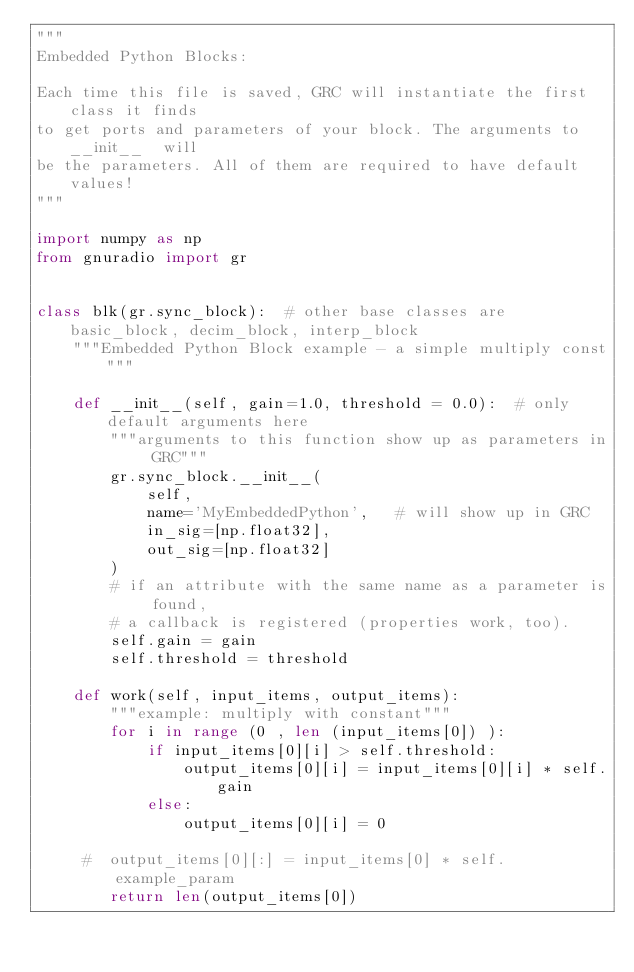<code> <loc_0><loc_0><loc_500><loc_500><_Python_>"""
Embedded Python Blocks:

Each time this file is saved, GRC will instantiate the first class it finds
to get ports and parameters of your block. The arguments to __init__  will
be the parameters. All of them are required to have default values!
"""

import numpy as np
from gnuradio import gr


class blk(gr.sync_block):  # other base classes are basic_block, decim_block, interp_block
    """Embedded Python Block example - a simple multiply const"""

    def __init__(self, gain=1.0, threshold = 0.0):  # only default arguments here
        """arguments to this function show up as parameters in GRC"""
        gr.sync_block.__init__(
            self,
            name='MyEmbeddedPython',   # will show up in GRC
            in_sig=[np.float32],
            out_sig=[np.float32]
        )
        # if an attribute with the same name as a parameter is found,
        # a callback is registered (properties work, too).
        self.gain = gain
        self.threshold = threshold 

    def work(self, input_items, output_items):
        """example: multiply with constant"""
        for i in range (0 , len (input_items[0]) ):
        	if input_items[0][i] > self.threshold:
        		output_items[0][i] = input_items[0][i] * self.gain
        	else:
        		output_items[0][i] = 0
        
     #  output_items[0][:] = input_items[0] * self.example_param
        return len(output_items[0])
        </code> 